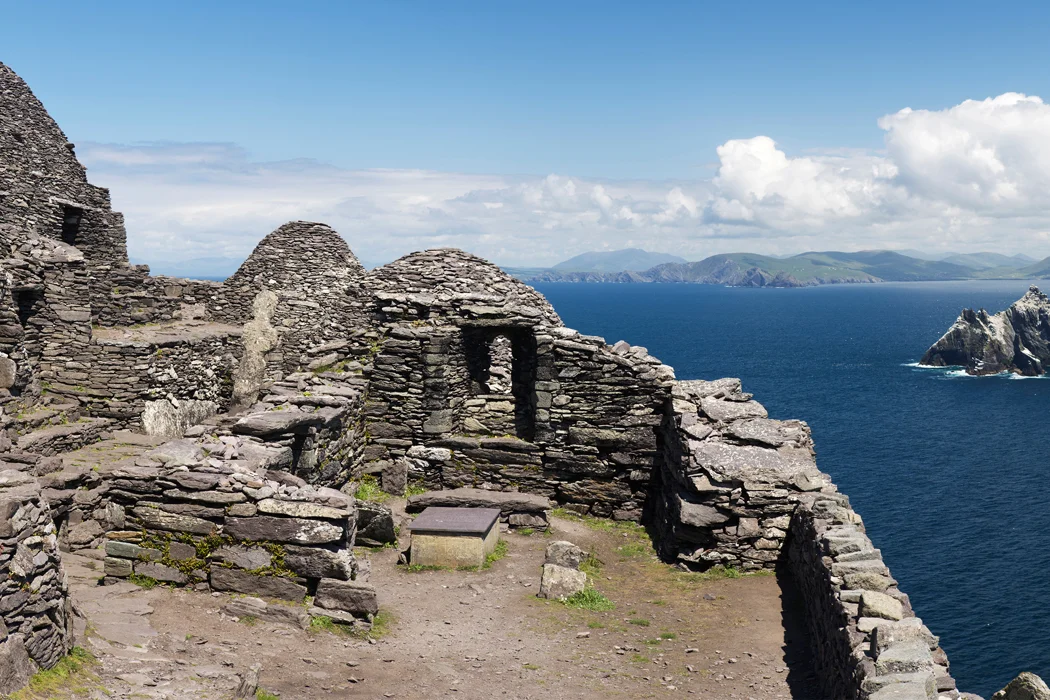Can you tell me more about the historical significance of Skellig Michael? Skellig Michael is a UNESCO World Heritage site, revered for its well-preserved monastic outpost of early Christianity. Founded between the 6th and 8th centuries, it represents a unique historical record of monastic life during this period. The monks lived in isolation, braving harsh weather conditions, and this rugged landscape to maintain their spiritual commitments away from mainland society. The site's historical importance is further marked by its strategic location for spiritual retreat and its architectural innovations typical of early Christian monasticism. 